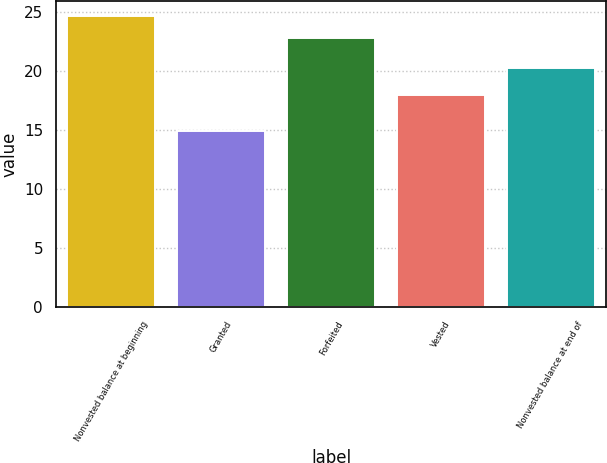Convert chart. <chart><loc_0><loc_0><loc_500><loc_500><bar_chart><fcel>Nonvested balance at beginning<fcel>Granted<fcel>Forfeited<fcel>Vested<fcel>Nonvested balance at end of<nl><fcel>24.65<fcel>14.89<fcel>22.77<fcel>17.94<fcel>20.2<nl></chart> 